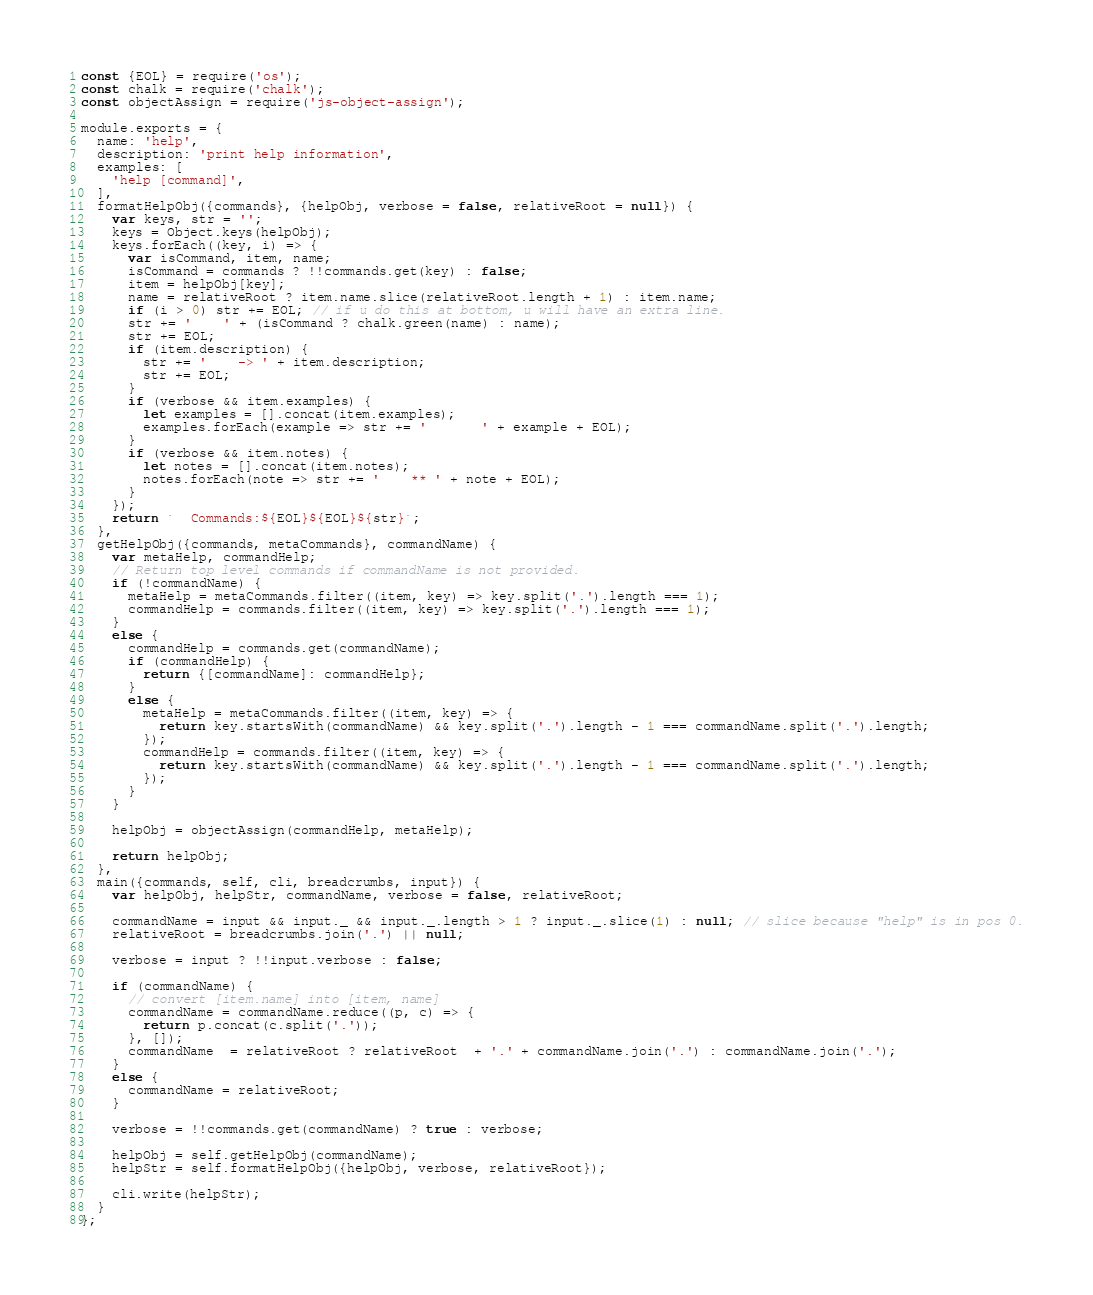Convert code to text. <code><loc_0><loc_0><loc_500><loc_500><_JavaScript_>const {EOL} = require('os');
const chalk = require('chalk');
const objectAssign = require('js-object-assign');

module.exports = {
  name: 'help',
  description: 'print help information',
  examples: [
    'help [command]',
  ],
  formatHelpObj({commands}, {helpObj, verbose = false, relativeRoot = null}) {
    var keys, str = '';
    keys = Object.keys(helpObj);
    keys.forEach((key, i) => {
      var isCommand, item, name;
      isCommand = commands ? !!commands.get(key) : false;
      item = helpObj[key];
      name = relativeRoot ? item.name.slice(relativeRoot.length + 1) : item.name;
      if (i > 0) str += EOL; // if u do this at bottom, u will have an extra line.
      str += '    ' + (isCommand ? chalk.green(name) : name);
      str += EOL;
      if (item.description) {
        str += '    -> ' + item.description;
        str += EOL;
      }
      if (verbose && item.examples) {
        let examples = [].concat(item.examples);
        examples.forEach(example => str += '       ' + example + EOL);
      }
      if (verbose && item.notes) {
        let notes = [].concat(item.notes);
        notes.forEach(note => str += '    ** ' + note + EOL);
      }
    });
    return `  Commands:${EOL}${EOL}${str}`;
  },
  getHelpObj({commands, metaCommands}, commandName) {
    var metaHelp, commandHelp;
    // Return top level commands if commandName is not provided.
    if (!commandName) {
      metaHelp = metaCommands.filter((item, key) => key.split('.').length === 1);
      commandHelp = commands.filter((item, key) => key.split('.').length === 1);
    }
    else {
      commandHelp = commands.get(commandName);
      if (commandHelp) {
        return {[commandName]: commandHelp};
      }
      else {
        metaHelp = metaCommands.filter((item, key) => {
          return key.startsWith(commandName) && key.split('.').length - 1 === commandName.split('.').length;
        });
        commandHelp = commands.filter((item, key) => {
          return key.startsWith(commandName) && key.split('.').length - 1 === commandName.split('.').length;
        });
      }
    }

    helpObj = objectAssign(commandHelp, metaHelp);

    return helpObj;
  },
  main({commands, self, cli, breadcrumbs, input}) {
    var helpObj, helpStr, commandName, verbose = false, relativeRoot;

    commandName = input && input._ && input._.length > 1 ? input._.slice(1) : null; // slice because "help" is in pos 0.
    relativeRoot = breadcrumbs.join('.') || null;

    verbose = input ? !!input.verbose : false;

    if (commandName) {
      // convert [item.name] into [item, name]
      commandName = commandName.reduce((p, c) => {
        return p.concat(c.split('.'));
      }, []);
      commandName  = relativeRoot ? relativeRoot  + '.' + commandName.join('.') : commandName.join('.');
    }
    else {
      commandName = relativeRoot;
    }

    verbose = !!commands.get(commandName) ? true : verbose;

    helpObj = self.getHelpObj(commandName);
    helpStr = self.formatHelpObj({helpObj, verbose, relativeRoot});

    cli.write(helpStr);
  }
};
</code> 